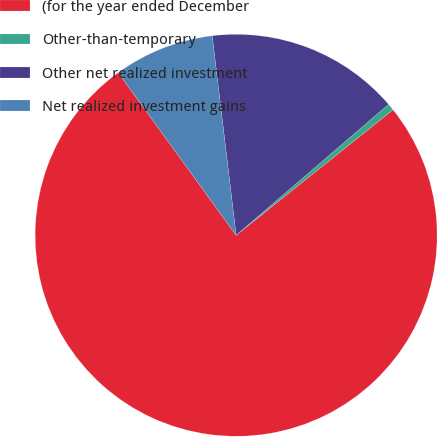<chart> <loc_0><loc_0><loc_500><loc_500><pie_chart><fcel>(for the year ended December<fcel>Other-than-temporary<fcel>Other net realized investment<fcel>Net realized investment gains<nl><fcel>75.75%<fcel>0.56%<fcel>15.6%<fcel>8.08%<nl></chart> 